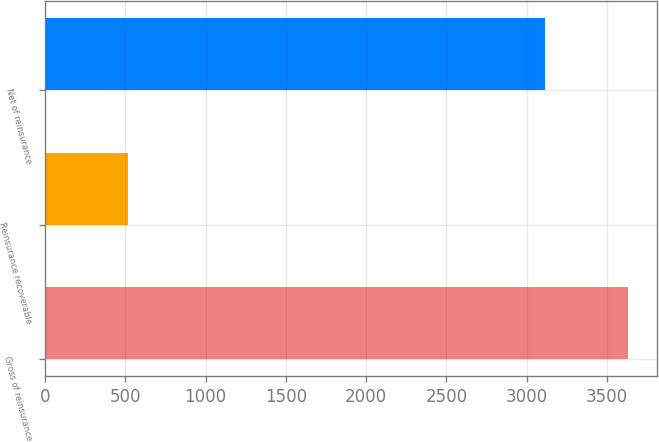Convert chart. <chart><loc_0><loc_0><loc_500><loc_500><bar_chart><fcel>Gross of reinsurance<fcel>Reinsurance recoverable<fcel>Net of reinsurance<nl><fcel>3629<fcel>518<fcel>3111<nl></chart> 